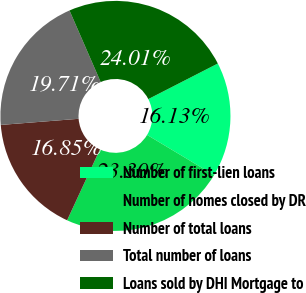Convert chart. <chart><loc_0><loc_0><loc_500><loc_500><pie_chart><fcel>Number of first-lien loans<fcel>Number of homes closed by DR<fcel>Number of total loans<fcel>Total number of loans<fcel>Loans sold by DHI Mortgage to<nl><fcel>16.13%<fcel>23.3%<fcel>16.85%<fcel>19.71%<fcel>24.01%<nl></chart> 